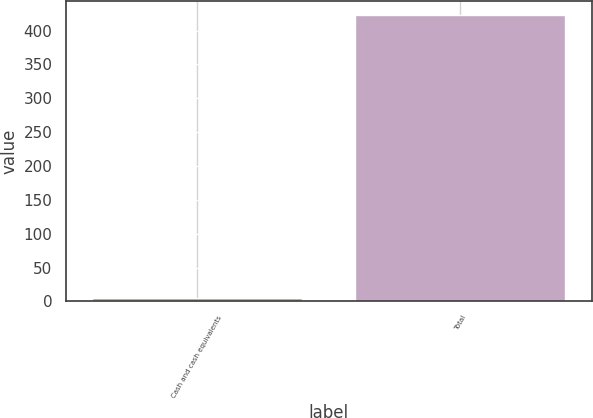Convert chart to OTSL. <chart><loc_0><loc_0><loc_500><loc_500><bar_chart><fcel>Cash and cash equivalents<fcel>Total<nl><fcel>5.2<fcel>422.7<nl></chart> 